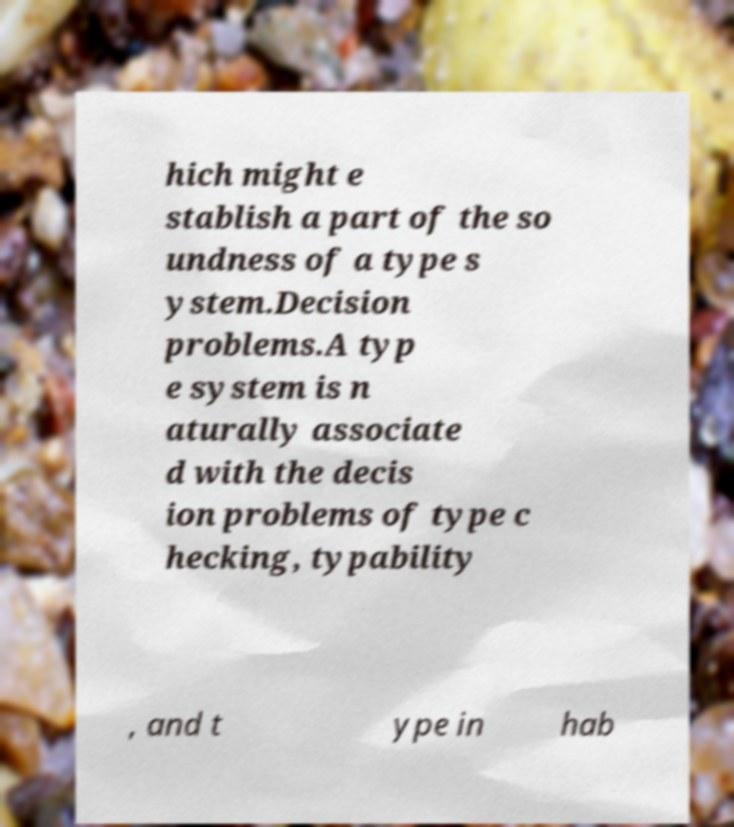Please identify and transcribe the text found in this image. hich might e stablish a part of the so undness of a type s ystem.Decision problems.A typ e system is n aturally associate d with the decis ion problems of type c hecking, typability , and t ype in hab 